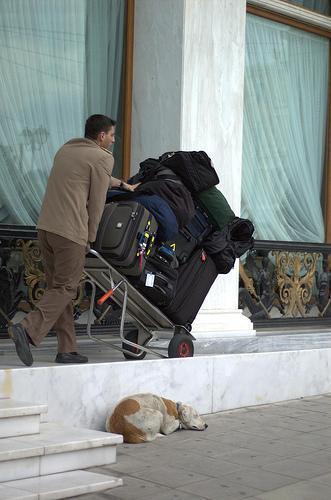How many people are pictured here?
Give a very brief answer. 1. 